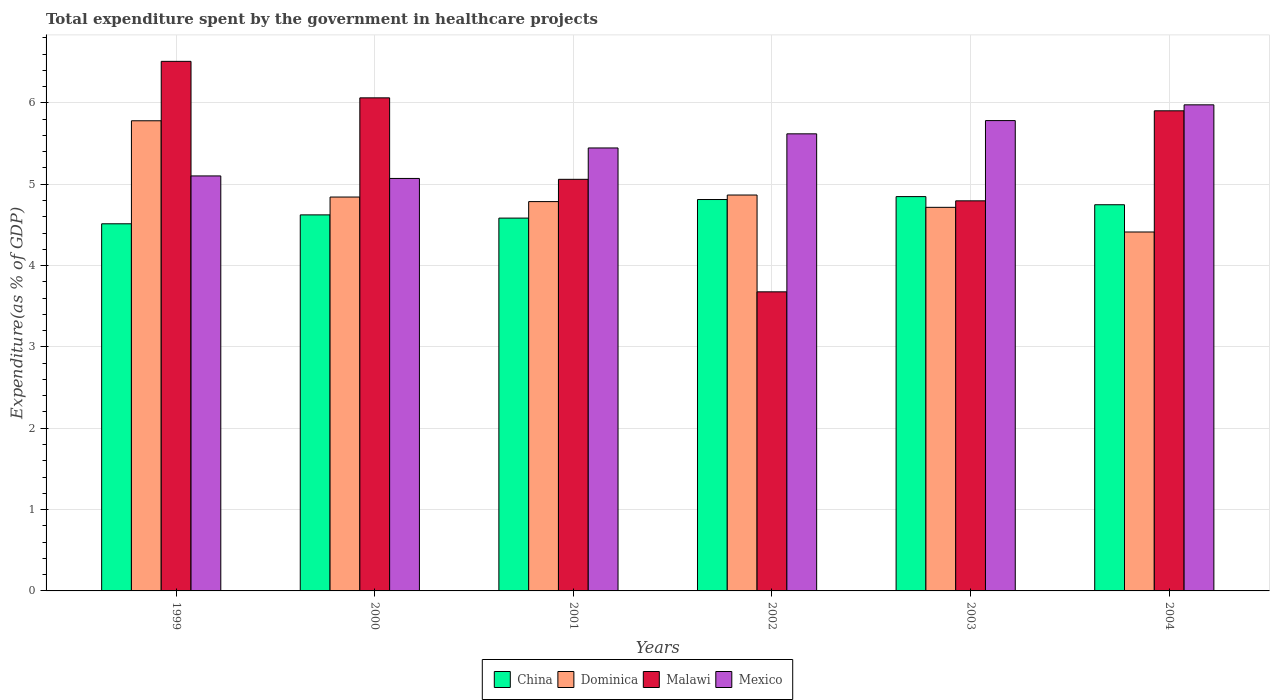How many different coloured bars are there?
Make the answer very short. 4. How many groups of bars are there?
Keep it short and to the point. 6. Are the number of bars on each tick of the X-axis equal?
Offer a very short reply. Yes. How many bars are there on the 1st tick from the right?
Offer a terse response. 4. What is the label of the 3rd group of bars from the left?
Ensure brevity in your answer.  2001. What is the total expenditure spent by the government in healthcare projects in China in 1999?
Provide a short and direct response. 4.51. Across all years, what is the maximum total expenditure spent by the government in healthcare projects in Mexico?
Offer a terse response. 5.98. Across all years, what is the minimum total expenditure spent by the government in healthcare projects in Malawi?
Provide a succinct answer. 3.68. In which year was the total expenditure spent by the government in healthcare projects in China minimum?
Offer a very short reply. 1999. What is the total total expenditure spent by the government in healthcare projects in Malawi in the graph?
Your answer should be compact. 32.01. What is the difference between the total expenditure spent by the government in healthcare projects in Malawi in 2003 and that in 2004?
Give a very brief answer. -1.11. What is the difference between the total expenditure spent by the government in healthcare projects in China in 2003 and the total expenditure spent by the government in healthcare projects in Mexico in 2001?
Ensure brevity in your answer.  -0.6. What is the average total expenditure spent by the government in healthcare projects in Dominica per year?
Ensure brevity in your answer.  4.9. In the year 1999, what is the difference between the total expenditure spent by the government in healthcare projects in Dominica and total expenditure spent by the government in healthcare projects in Malawi?
Give a very brief answer. -0.73. In how many years, is the total expenditure spent by the government in healthcare projects in Dominica greater than 3.4 %?
Provide a short and direct response. 6. What is the ratio of the total expenditure spent by the government in healthcare projects in Malawi in 2002 to that in 2003?
Keep it short and to the point. 0.77. What is the difference between the highest and the second highest total expenditure spent by the government in healthcare projects in Mexico?
Offer a very short reply. 0.19. What is the difference between the highest and the lowest total expenditure spent by the government in healthcare projects in China?
Give a very brief answer. 0.33. In how many years, is the total expenditure spent by the government in healthcare projects in Mexico greater than the average total expenditure spent by the government in healthcare projects in Mexico taken over all years?
Provide a short and direct response. 3. Is the sum of the total expenditure spent by the government in healthcare projects in Mexico in 2001 and 2002 greater than the maximum total expenditure spent by the government in healthcare projects in Dominica across all years?
Make the answer very short. Yes. What does the 4th bar from the right in 1999 represents?
Provide a short and direct response. China. Is it the case that in every year, the sum of the total expenditure spent by the government in healthcare projects in China and total expenditure spent by the government in healthcare projects in Malawi is greater than the total expenditure spent by the government in healthcare projects in Mexico?
Your answer should be compact. Yes. How many bars are there?
Provide a short and direct response. 24. Are all the bars in the graph horizontal?
Offer a terse response. No. How many years are there in the graph?
Keep it short and to the point. 6. What is the difference between two consecutive major ticks on the Y-axis?
Keep it short and to the point. 1. Are the values on the major ticks of Y-axis written in scientific E-notation?
Your answer should be compact. No. Does the graph contain any zero values?
Offer a terse response. No. Does the graph contain grids?
Provide a short and direct response. Yes. Where does the legend appear in the graph?
Offer a terse response. Bottom center. What is the title of the graph?
Give a very brief answer. Total expenditure spent by the government in healthcare projects. What is the label or title of the Y-axis?
Keep it short and to the point. Expenditure(as % of GDP). What is the Expenditure(as % of GDP) in China in 1999?
Keep it short and to the point. 4.51. What is the Expenditure(as % of GDP) in Dominica in 1999?
Offer a terse response. 5.78. What is the Expenditure(as % of GDP) of Malawi in 1999?
Keep it short and to the point. 6.51. What is the Expenditure(as % of GDP) of Mexico in 1999?
Your answer should be compact. 5.1. What is the Expenditure(as % of GDP) of China in 2000?
Ensure brevity in your answer.  4.62. What is the Expenditure(as % of GDP) in Dominica in 2000?
Your answer should be very brief. 4.84. What is the Expenditure(as % of GDP) in Malawi in 2000?
Your response must be concise. 6.06. What is the Expenditure(as % of GDP) in Mexico in 2000?
Provide a succinct answer. 5.07. What is the Expenditure(as % of GDP) of China in 2001?
Offer a very short reply. 4.58. What is the Expenditure(as % of GDP) of Dominica in 2001?
Give a very brief answer. 4.79. What is the Expenditure(as % of GDP) in Malawi in 2001?
Provide a succinct answer. 5.06. What is the Expenditure(as % of GDP) in Mexico in 2001?
Provide a short and direct response. 5.45. What is the Expenditure(as % of GDP) of China in 2002?
Offer a terse response. 4.81. What is the Expenditure(as % of GDP) in Dominica in 2002?
Ensure brevity in your answer.  4.87. What is the Expenditure(as % of GDP) in Malawi in 2002?
Give a very brief answer. 3.68. What is the Expenditure(as % of GDP) in Mexico in 2002?
Provide a short and direct response. 5.62. What is the Expenditure(as % of GDP) of China in 2003?
Your response must be concise. 4.85. What is the Expenditure(as % of GDP) in Dominica in 2003?
Keep it short and to the point. 4.72. What is the Expenditure(as % of GDP) of Malawi in 2003?
Provide a short and direct response. 4.8. What is the Expenditure(as % of GDP) in Mexico in 2003?
Provide a short and direct response. 5.78. What is the Expenditure(as % of GDP) in China in 2004?
Keep it short and to the point. 4.75. What is the Expenditure(as % of GDP) in Dominica in 2004?
Your answer should be compact. 4.41. What is the Expenditure(as % of GDP) of Malawi in 2004?
Provide a short and direct response. 5.9. What is the Expenditure(as % of GDP) of Mexico in 2004?
Your answer should be compact. 5.98. Across all years, what is the maximum Expenditure(as % of GDP) of China?
Give a very brief answer. 4.85. Across all years, what is the maximum Expenditure(as % of GDP) of Dominica?
Provide a succinct answer. 5.78. Across all years, what is the maximum Expenditure(as % of GDP) of Malawi?
Offer a terse response. 6.51. Across all years, what is the maximum Expenditure(as % of GDP) in Mexico?
Give a very brief answer. 5.98. Across all years, what is the minimum Expenditure(as % of GDP) in China?
Offer a very short reply. 4.51. Across all years, what is the minimum Expenditure(as % of GDP) of Dominica?
Your response must be concise. 4.41. Across all years, what is the minimum Expenditure(as % of GDP) in Malawi?
Provide a succinct answer. 3.68. Across all years, what is the minimum Expenditure(as % of GDP) of Mexico?
Offer a very short reply. 5.07. What is the total Expenditure(as % of GDP) of China in the graph?
Offer a very short reply. 28.13. What is the total Expenditure(as % of GDP) in Dominica in the graph?
Make the answer very short. 29.4. What is the total Expenditure(as % of GDP) of Malawi in the graph?
Provide a succinct answer. 32.01. What is the total Expenditure(as % of GDP) in Mexico in the graph?
Provide a short and direct response. 33. What is the difference between the Expenditure(as % of GDP) of China in 1999 and that in 2000?
Offer a terse response. -0.11. What is the difference between the Expenditure(as % of GDP) in Dominica in 1999 and that in 2000?
Offer a terse response. 0.94. What is the difference between the Expenditure(as % of GDP) of Malawi in 1999 and that in 2000?
Provide a succinct answer. 0.45. What is the difference between the Expenditure(as % of GDP) of Mexico in 1999 and that in 2000?
Keep it short and to the point. 0.03. What is the difference between the Expenditure(as % of GDP) of China in 1999 and that in 2001?
Offer a terse response. -0.07. What is the difference between the Expenditure(as % of GDP) of Malawi in 1999 and that in 2001?
Your answer should be very brief. 1.45. What is the difference between the Expenditure(as % of GDP) in Mexico in 1999 and that in 2001?
Keep it short and to the point. -0.34. What is the difference between the Expenditure(as % of GDP) in China in 1999 and that in 2002?
Provide a short and direct response. -0.3. What is the difference between the Expenditure(as % of GDP) of Dominica in 1999 and that in 2002?
Give a very brief answer. 0.91. What is the difference between the Expenditure(as % of GDP) in Malawi in 1999 and that in 2002?
Ensure brevity in your answer.  2.83. What is the difference between the Expenditure(as % of GDP) of Mexico in 1999 and that in 2002?
Your answer should be compact. -0.52. What is the difference between the Expenditure(as % of GDP) of China in 1999 and that in 2003?
Your answer should be compact. -0.33. What is the difference between the Expenditure(as % of GDP) of Dominica in 1999 and that in 2003?
Provide a succinct answer. 1.06. What is the difference between the Expenditure(as % of GDP) in Malawi in 1999 and that in 2003?
Give a very brief answer. 1.71. What is the difference between the Expenditure(as % of GDP) in Mexico in 1999 and that in 2003?
Your answer should be very brief. -0.68. What is the difference between the Expenditure(as % of GDP) of China in 1999 and that in 2004?
Offer a terse response. -0.23. What is the difference between the Expenditure(as % of GDP) of Dominica in 1999 and that in 2004?
Offer a terse response. 1.37. What is the difference between the Expenditure(as % of GDP) in Malawi in 1999 and that in 2004?
Your response must be concise. 0.61. What is the difference between the Expenditure(as % of GDP) of Mexico in 1999 and that in 2004?
Offer a terse response. -0.87. What is the difference between the Expenditure(as % of GDP) of China in 2000 and that in 2001?
Your answer should be very brief. 0.04. What is the difference between the Expenditure(as % of GDP) in Dominica in 2000 and that in 2001?
Ensure brevity in your answer.  0.06. What is the difference between the Expenditure(as % of GDP) in Malawi in 2000 and that in 2001?
Offer a very short reply. 1. What is the difference between the Expenditure(as % of GDP) of Mexico in 2000 and that in 2001?
Your answer should be very brief. -0.37. What is the difference between the Expenditure(as % of GDP) of China in 2000 and that in 2002?
Ensure brevity in your answer.  -0.19. What is the difference between the Expenditure(as % of GDP) of Dominica in 2000 and that in 2002?
Provide a short and direct response. -0.02. What is the difference between the Expenditure(as % of GDP) in Malawi in 2000 and that in 2002?
Make the answer very short. 2.38. What is the difference between the Expenditure(as % of GDP) of Mexico in 2000 and that in 2002?
Give a very brief answer. -0.55. What is the difference between the Expenditure(as % of GDP) in China in 2000 and that in 2003?
Your answer should be very brief. -0.22. What is the difference between the Expenditure(as % of GDP) of Dominica in 2000 and that in 2003?
Your answer should be very brief. 0.13. What is the difference between the Expenditure(as % of GDP) in Malawi in 2000 and that in 2003?
Your response must be concise. 1.27. What is the difference between the Expenditure(as % of GDP) in Mexico in 2000 and that in 2003?
Offer a very short reply. -0.71. What is the difference between the Expenditure(as % of GDP) in China in 2000 and that in 2004?
Give a very brief answer. -0.12. What is the difference between the Expenditure(as % of GDP) of Dominica in 2000 and that in 2004?
Make the answer very short. 0.43. What is the difference between the Expenditure(as % of GDP) in Malawi in 2000 and that in 2004?
Offer a very short reply. 0.16. What is the difference between the Expenditure(as % of GDP) in Mexico in 2000 and that in 2004?
Your response must be concise. -0.9. What is the difference between the Expenditure(as % of GDP) in China in 2001 and that in 2002?
Keep it short and to the point. -0.23. What is the difference between the Expenditure(as % of GDP) in Dominica in 2001 and that in 2002?
Offer a terse response. -0.08. What is the difference between the Expenditure(as % of GDP) of Malawi in 2001 and that in 2002?
Ensure brevity in your answer.  1.38. What is the difference between the Expenditure(as % of GDP) in Mexico in 2001 and that in 2002?
Your response must be concise. -0.17. What is the difference between the Expenditure(as % of GDP) in China in 2001 and that in 2003?
Offer a terse response. -0.26. What is the difference between the Expenditure(as % of GDP) in Dominica in 2001 and that in 2003?
Provide a succinct answer. 0.07. What is the difference between the Expenditure(as % of GDP) of Malawi in 2001 and that in 2003?
Make the answer very short. 0.26. What is the difference between the Expenditure(as % of GDP) in Mexico in 2001 and that in 2003?
Provide a short and direct response. -0.34. What is the difference between the Expenditure(as % of GDP) of China in 2001 and that in 2004?
Offer a very short reply. -0.16. What is the difference between the Expenditure(as % of GDP) in Dominica in 2001 and that in 2004?
Your answer should be compact. 0.37. What is the difference between the Expenditure(as % of GDP) of Malawi in 2001 and that in 2004?
Your response must be concise. -0.84. What is the difference between the Expenditure(as % of GDP) in Mexico in 2001 and that in 2004?
Your answer should be compact. -0.53. What is the difference between the Expenditure(as % of GDP) in China in 2002 and that in 2003?
Ensure brevity in your answer.  -0.04. What is the difference between the Expenditure(as % of GDP) in Dominica in 2002 and that in 2003?
Keep it short and to the point. 0.15. What is the difference between the Expenditure(as % of GDP) of Malawi in 2002 and that in 2003?
Give a very brief answer. -1.12. What is the difference between the Expenditure(as % of GDP) in Mexico in 2002 and that in 2003?
Your answer should be very brief. -0.16. What is the difference between the Expenditure(as % of GDP) of China in 2002 and that in 2004?
Offer a terse response. 0.06. What is the difference between the Expenditure(as % of GDP) in Dominica in 2002 and that in 2004?
Offer a terse response. 0.45. What is the difference between the Expenditure(as % of GDP) in Malawi in 2002 and that in 2004?
Make the answer very short. -2.23. What is the difference between the Expenditure(as % of GDP) of Mexico in 2002 and that in 2004?
Ensure brevity in your answer.  -0.36. What is the difference between the Expenditure(as % of GDP) in China in 2003 and that in 2004?
Offer a very short reply. 0.1. What is the difference between the Expenditure(as % of GDP) of Dominica in 2003 and that in 2004?
Ensure brevity in your answer.  0.3. What is the difference between the Expenditure(as % of GDP) of Malawi in 2003 and that in 2004?
Offer a very short reply. -1.11. What is the difference between the Expenditure(as % of GDP) of Mexico in 2003 and that in 2004?
Offer a very short reply. -0.19. What is the difference between the Expenditure(as % of GDP) of China in 1999 and the Expenditure(as % of GDP) of Dominica in 2000?
Offer a very short reply. -0.33. What is the difference between the Expenditure(as % of GDP) of China in 1999 and the Expenditure(as % of GDP) of Malawi in 2000?
Provide a succinct answer. -1.55. What is the difference between the Expenditure(as % of GDP) in China in 1999 and the Expenditure(as % of GDP) in Mexico in 2000?
Make the answer very short. -0.56. What is the difference between the Expenditure(as % of GDP) in Dominica in 1999 and the Expenditure(as % of GDP) in Malawi in 2000?
Your response must be concise. -0.28. What is the difference between the Expenditure(as % of GDP) of Dominica in 1999 and the Expenditure(as % of GDP) of Mexico in 2000?
Offer a terse response. 0.71. What is the difference between the Expenditure(as % of GDP) in Malawi in 1999 and the Expenditure(as % of GDP) in Mexico in 2000?
Make the answer very short. 1.44. What is the difference between the Expenditure(as % of GDP) of China in 1999 and the Expenditure(as % of GDP) of Dominica in 2001?
Provide a succinct answer. -0.27. What is the difference between the Expenditure(as % of GDP) of China in 1999 and the Expenditure(as % of GDP) of Malawi in 2001?
Offer a very short reply. -0.55. What is the difference between the Expenditure(as % of GDP) in China in 1999 and the Expenditure(as % of GDP) in Mexico in 2001?
Provide a succinct answer. -0.93. What is the difference between the Expenditure(as % of GDP) of Dominica in 1999 and the Expenditure(as % of GDP) of Malawi in 2001?
Make the answer very short. 0.72. What is the difference between the Expenditure(as % of GDP) in Dominica in 1999 and the Expenditure(as % of GDP) in Mexico in 2001?
Your response must be concise. 0.33. What is the difference between the Expenditure(as % of GDP) of Malawi in 1999 and the Expenditure(as % of GDP) of Mexico in 2001?
Give a very brief answer. 1.06. What is the difference between the Expenditure(as % of GDP) of China in 1999 and the Expenditure(as % of GDP) of Dominica in 2002?
Give a very brief answer. -0.35. What is the difference between the Expenditure(as % of GDP) of China in 1999 and the Expenditure(as % of GDP) of Malawi in 2002?
Make the answer very short. 0.84. What is the difference between the Expenditure(as % of GDP) in China in 1999 and the Expenditure(as % of GDP) in Mexico in 2002?
Offer a terse response. -1.11. What is the difference between the Expenditure(as % of GDP) in Dominica in 1999 and the Expenditure(as % of GDP) in Malawi in 2002?
Your answer should be compact. 2.1. What is the difference between the Expenditure(as % of GDP) in Dominica in 1999 and the Expenditure(as % of GDP) in Mexico in 2002?
Offer a very short reply. 0.16. What is the difference between the Expenditure(as % of GDP) in Malawi in 1999 and the Expenditure(as % of GDP) in Mexico in 2002?
Your response must be concise. 0.89. What is the difference between the Expenditure(as % of GDP) in China in 1999 and the Expenditure(as % of GDP) in Dominica in 2003?
Offer a very short reply. -0.2. What is the difference between the Expenditure(as % of GDP) of China in 1999 and the Expenditure(as % of GDP) of Malawi in 2003?
Keep it short and to the point. -0.28. What is the difference between the Expenditure(as % of GDP) in China in 1999 and the Expenditure(as % of GDP) in Mexico in 2003?
Provide a succinct answer. -1.27. What is the difference between the Expenditure(as % of GDP) of Dominica in 1999 and the Expenditure(as % of GDP) of Malawi in 2003?
Provide a succinct answer. 0.98. What is the difference between the Expenditure(as % of GDP) in Dominica in 1999 and the Expenditure(as % of GDP) in Mexico in 2003?
Offer a very short reply. -0. What is the difference between the Expenditure(as % of GDP) of Malawi in 1999 and the Expenditure(as % of GDP) of Mexico in 2003?
Give a very brief answer. 0.73. What is the difference between the Expenditure(as % of GDP) in China in 1999 and the Expenditure(as % of GDP) in Dominica in 2004?
Provide a short and direct response. 0.1. What is the difference between the Expenditure(as % of GDP) in China in 1999 and the Expenditure(as % of GDP) in Malawi in 2004?
Your answer should be compact. -1.39. What is the difference between the Expenditure(as % of GDP) of China in 1999 and the Expenditure(as % of GDP) of Mexico in 2004?
Offer a terse response. -1.46. What is the difference between the Expenditure(as % of GDP) in Dominica in 1999 and the Expenditure(as % of GDP) in Malawi in 2004?
Make the answer very short. -0.12. What is the difference between the Expenditure(as % of GDP) of Dominica in 1999 and the Expenditure(as % of GDP) of Mexico in 2004?
Provide a short and direct response. -0.2. What is the difference between the Expenditure(as % of GDP) of Malawi in 1999 and the Expenditure(as % of GDP) of Mexico in 2004?
Offer a terse response. 0.53. What is the difference between the Expenditure(as % of GDP) of China in 2000 and the Expenditure(as % of GDP) of Dominica in 2001?
Give a very brief answer. -0.16. What is the difference between the Expenditure(as % of GDP) in China in 2000 and the Expenditure(as % of GDP) in Malawi in 2001?
Ensure brevity in your answer.  -0.44. What is the difference between the Expenditure(as % of GDP) in China in 2000 and the Expenditure(as % of GDP) in Mexico in 2001?
Offer a terse response. -0.82. What is the difference between the Expenditure(as % of GDP) of Dominica in 2000 and the Expenditure(as % of GDP) of Malawi in 2001?
Keep it short and to the point. -0.22. What is the difference between the Expenditure(as % of GDP) in Dominica in 2000 and the Expenditure(as % of GDP) in Mexico in 2001?
Make the answer very short. -0.6. What is the difference between the Expenditure(as % of GDP) in Malawi in 2000 and the Expenditure(as % of GDP) in Mexico in 2001?
Provide a succinct answer. 0.62. What is the difference between the Expenditure(as % of GDP) of China in 2000 and the Expenditure(as % of GDP) of Dominica in 2002?
Provide a succinct answer. -0.24. What is the difference between the Expenditure(as % of GDP) of China in 2000 and the Expenditure(as % of GDP) of Malawi in 2002?
Ensure brevity in your answer.  0.95. What is the difference between the Expenditure(as % of GDP) of China in 2000 and the Expenditure(as % of GDP) of Mexico in 2002?
Provide a short and direct response. -1. What is the difference between the Expenditure(as % of GDP) of Dominica in 2000 and the Expenditure(as % of GDP) of Malawi in 2002?
Offer a terse response. 1.17. What is the difference between the Expenditure(as % of GDP) of Dominica in 2000 and the Expenditure(as % of GDP) of Mexico in 2002?
Offer a terse response. -0.78. What is the difference between the Expenditure(as % of GDP) of Malawi in 2000 and the Expenditure(as % of GDP) of Mexico in 2002?
Provide a succinct answer. 0.44. What is the difference between the Expenditure(as % of GDP) in China in 2000 and the Expenditure(as % of GDP) in Dominica in 2003?
Offer a very short reply. -0.09. What is the difference between the Expenditure(as % of GDP) in China in 2000 and the Expenditure(as % of GDP) in Malawi in 2003?
Offer a very short reply. -0.17. What is the difference between the Expenditure(as % of GDP) of China in 2000 and the Expenditure(as % of GDP) of Mexico in 2003?
Give a very brief answer. -1.16. What is the difference between the Expenditure(as % of GDP) in Dominica in 2000 and the Expenditure(as % of GDP) in Malawi in 2003?
Provide a short and direct response. 0.05. What is the difference between the Expenditure(as % of GDP) in Dominica in 2000 and the Expenditure(as % of GDP) in Mexico in 2003?
Give a very brief answer. -0.94. What is the difference between the Expenditure(as % of GDP) of Malawi in 2000 and the Expenditure(as % of GDP) of Mexico in 2003?
Give a very brief answer. 0.28. What is the difference between the Expenditure(as % of GDP) in China in 2000 and the Expenditure(as % of GDP) in Dominica in 2004?
Make the answer very short. 0.21. What is the difference between the Expenditure(as % of GDP) in China in 2000 and the Expenditure(as % of GDP) in Malawi in 2004?
Offer a very short reply. -1.28. What is the difference between the Expenditure(as % of GDP) in China in 2000 and the Expenditure(as % of GDP) in Mexico in 2004?
Provide a succinct answer. -1.35. What is the difference between the Expenditure(as % of GDP) in Dominica in 2000 and the Expenditure(as % of GDP) in Malawi in 2004?
Your response must be concise. -1.06. What is the difference between the Expenditure(as % of GDP) of Dominica in 2000 and the Expenditure(as % of GDP) of Mexico in 2004?
Keep it short and to the point. -1.13. What is the difference between the Expenditure(as % of GDP) of Malawi in 2000 and the Expenditure(as % of GDP) of Mexico in 2004?
Make the answer very short. 0.09. What is the difference between the Expenditure(as % of GDP) of China in 2001 and the Expenditure(as % of GDP) of Dominica in 2002?
Provide a short and direct response. -0.28. What is the difference between the Expenditure(as % of GDP) of China in 2001 and the Expenditure(as % of GDP) of Malawi in 2002?
Give a very brief answer. 0.91. What is the difference between the Expenditure(as % of GDP) of China in 2001 and the Expenditure(as % of GDP) of Mexico in 2002?
Ensure brevity in your answer.  -1.04. What is the difference between the Expenditure(as % of GDP) of Dominica in 2001 and the Expenditure(as % of GDP) of Malawi in 2002?
Make the answer very short. 1.11. What is the difference between the Expenditure(as % of GDP) in Dominica in 2001 and the Expenditure(as % of GDP) in Mexico in 2002?
Your answer should be very brief. -0.83. What is the difference between the Expenditure(as % of GDP) of Malawi in 2001 and the Expenditure(as % of GDP) of Mexico in 2002?
Your answer should be very brief. -0.56. What is the difference between the Expenditure(as % of GDP) in China in 2001 and the Expenditure(as % of GDP) in Dominica in 2003?
Ensure brevity in your answer.  -0.13. What is the difference between the Expenditure(as % of GDP) in China in 2001 and the Expenditure(as % of GDP) in Malawi in 2003?
Give a very brief answer. -0.21. What is the difference between the Expenditure(as % of GDP) in China in 2001 and the Expenditure(as % of GDP) in Mexico in 2003?
Give a very brief answer. -1.2. What is the difference between the Expenditure(as % of GDP) in Dominica in 2001 and the Expenditure(as % of GDP) in Malawi in 2003?
Offer a very short reply. -0.01. What is the difference between the Expenditure(as % of GDP) in Dominica in 2001 and the Expenditure(as % of GDP) in Mexico in 2003?
Your answer should be compact. -1. What is the difference between the Expenditure(as % of GDP) in Malawi in 2001 and the Expenditure(as % of GDP) in Mexico in 2003?
Make the answer very short. -0.72. What is the difference between the Expenditure(as % of GDP) of China in 2001 and the Expenditure(as % of GDP) of Dominica in 2004?
Give a very brief answer. 0.17. What is the difference between the Expenditure(as % of GDP) of China in 2001 and the Expenditure(as % of GDP) of Malawi in 2004?
Offer a terse response. -1.32. What is the difference between the Expenditure(as % of GDP) in China in 2001 and the Expenditure(as % of GDP) in Mexico in 2004?
Offer a terse response. -1.39. What is the difference between the Expenditure(as % of GDP) of Dominica in 2001 and the Expenditure(as % of GDP) of Malawi in 2004?
Offer a very short reply. -1.12. What is the difference between the Expenditure(as % of GDP) of Dominica in 2001 and the Expenditure(as % of GDP) of Mexico in 2004?
Offer a terse response. -1.19. What is the difference between the Expenditure(as % of GDP) of Malawi in 2001 and the Expenditure(as % of GDP) of Mexico in 2004?
Provide a succinct answer. -0.92. What is the difference between the Expenditure(as % of GDP) in China in 2002 and the Expenditure(as % of GDP) in Dominica in 2003?
Offer a very short reply. 0.1. What is the difference between the Expenditure(as % of GDP) in China in 2002 and the Expenditure(as % of GDP) in Malawi in 2003?
Ensure brevity in your answer.  0.02. What is the difference between the Expenditure(as % of GDP) in China in 2002 and the Expenditure(as % of GDP) in Mexico in 2003?
Give a very brief answer. -0.97. What is the difference between the Expenditure(as % of GDP) in Dominica in 2002 and the Expenditure(as % of GDP) in Malawi in 2003?
Your response must be concise. 0.07. What is the difference between the Expenditure(as % of GDP) of Dominica in 2002 and the Expenditure(as % of GDP) of Mexico in 2003?
Your answer should be compact. -0.92. What is the difference between the Expenditure(as % of GDP) in Malawi in 2002 and the Expenditure(as % of GDP) in Mexico in 2003?
Keep it short and to the point. -2.11. What is the difference between the Expenditure(as % of GDP) of China in 2002 and the Expenditure(as % of GDP) of Dominica in 2004?
Your answer should be very brief. 0.4. What is the difference between the Expenditure(as % of GDP) of China in 2002 and the Expenditure(as % of GDP) of Malawi in 2004?
Offer a terse response. -1.09. What is the difference between the Expenditure(as % of GDP) in China in 2002 and the Expenditure(as % of GDP) in Mexico in 2004?
Ensure brevity in your answer.  -1.16. What is the difference between the Expenditure(as % of GDP) in Dominica in 2002 and the Expenditure(as % of GDP) in Malawi in 2004?
Ensure brevity in your answer.  -1.04. What is the difference between the Expenditure(as % of GDP) in Dominica in 2002 and the Expenditure(as % of GDP) in Mexico in 2004?
Offer a very short reply. -1.11. What is the difference between the Expenditure(as % of GDP) of Malawi in 2002 and the Expenditure(as % of GDP) of Mexico in 2004?
Provide a short and direct response. -2.3. What is the difference between the Expenditure(as % of GDP) of China in 2003 and the Expenditure(as % of GDP) of Dominica in 2004?
Your answer should be compact. 0.43. What is the difference between the Expenditure(as % of GDP) in China in 2003 and the Expenditure(as % of GDP) in Malawi in 2004?
Provide a short and direct response. -1.05. What is the difference between the Expenditure(as % of GDP) in China in 2003 and the Expenditure(as % of GDP) in Mexico in 2004?
Offer a terse response. -1.13. What is the difference between the Expenditure(as % of GDP) in Dominica in 2003 and the Expenditure(as % of GDP) in Malawi in 2004?
Give a very brief answer. -1.19. What is the difference between the Expenditure(as % of GDP) of Dominica in 2003 and the Expenditure(as % of GDP) of Mexico in 2004?
Provide a succinct answer. -1.26. What is the difference between the Expenditure(as % of GDP) of Malawi in 2003 and the Expenditure(as % of GDP) of Mexico in 2004?
Offer a terse response. -1.18. What is the average Expenditure(as % of GDP) of China per year?
Give a very brief answer. 4.69. What is the average Expenditure(as % of GDP) of Dominica per year?
Make the answer very short. 4.9. What is the average Expenditure(as % of GDP) in Malawi per year?
Your answer should be compact. 5.33. What is the average Expenditure(as % of GDP) in Mexico per year?
Offer a very short reply. 5.5. In the year 1999, what is the difference between the Expenditure(as % of GDP) in China and Expenditure(as % of GDP) in Dominica?
Keep it short and to the point. -1.27. In the year 1999, what is the difference between the Expenditure(as % of GDP) of China and Expenditure(as % of GDP) of Malawi?
Provide a short and direct response. -2. In the year 1999, what is the difference between the Expenditure(as % of GDP) in China and Expenditure(as % of GDP) in Mexico?
Ensure brevity in your answer.  -0.59. In the year 1999, what is the difference between the Expenditure(as % of GDP) in Dominica and Expenditure(as % of GDP) in Malawi?
Provide a succinct answer. -0.73. In the year 1999, what is the difference between the Expenditure(as % of GDP) in Dominica and Expenditure(as % of GDP) in Mexico?
Ensure brevity in your answer.  0.68. In the year 1999, what is the difference between the Expenditure(as % of GDP) in Malawi and Expenditure(as % of GDP) in Mexico?
Ensure brevity in your answer.  1.41. In the year 2000, what is the difference between the Expenditure(as % of GDP) of China and Expenditure(as % of GDP) of Dominica?
Offer a terse response. -0.22. In the year 2000, what is the difference between the Expenditure(as % of GDP) of China and Expenditure(as % of GDP) of Malawi?
Keep it short and to the point. -1.44. In the year 2000, what is the difference between the Expenditure(as % of GDP) of China and Expenditure(as % of GDP) of Mexico?
Make the answer very short. -0.45. In the year 2000, what is the difference between the Expenditure(as % of GDP) in Dominica and Expenditure(as % of GDP) in Malawi?
Your answer should be compact. -1.22. In the year 2000, what is the difference between the Expenditure(as % of GDP) in Dominica and Expenditure(as % of GDP) in Mexico?
Your response must be concise. -0.23. In the year 2000, what is the difference between the Expenditure(as % of GDP) of Malawi and Expenditure(as % of GDP) of Mexico?
Keep it short and to the point. 0.99. In the year 2001, what is the difference between the Expenditure(as % of GDP) in China and Expenditure(as % of GDP) in Dominica?
Offer a very short reply. -0.2. In the year 2001, what is the difference between the Expenditure(as % of GDP) in China and Expenditure(as % of GDP) in Malawi?
Your answer should be compact. -0.48. In the year 2001, what is the difference between the Expenditure(as % of GDP) of China and Expenditure(as % of GDP) of Mexico?
Make the answer very short. -0.86. In the year 2001, what is the difference between the Expenditure(as % of GDP) of Dominica and Expenditure(as % of GDP) of Malawi?
Make the answer very short. -0.27. In the year 2001, what is the difference between the Expenditure(as % of GDP) in Dominica and Expenditure(as % of GDP) in Mexico?
Your answer should be very brief. -0.66. In the year 2001, what is the difference between the Expenditure(as % of GDP) in Malawi and Expenditure(as % of GDP) in Mexico?
Your response must be concise. -0.39. In the year 2002, what is the difference between the Expenditure(as % of GDP) in China and Expenditure(as % of GDP) in Dominica?
Provide a succinct answer. -0.06. In the year 2002, what is the difference between the Expenditure(as % of GDP) in China and Expenditure(as % of GDP) in Malawi?
Your answer should be compact. 1.13. In the year 2002, what is the difference between the Expenditure(as % of GDP) in China and Expenditure(as % of GDP) in Mexico?
Provide a short and direct response. -0.81. In the year 2002, what is the difference between the Expenditure(as % of GDP) in Dominica and Expenditure(as % of GDP) in Malawi?
Give a very brief answer. 1.19. In the year 2002, what is the difference between the Expenditure(as % of GDP) in Dominica and Expenditure(as % of GDP) in Mexico?
Your response must be concise. -0.75. In the year 2002, what is the difference between the Expenditure(as % of GDP) in Malawi and Expenditure(as % of GDP) in Mexico?
Make the answer very short. -1.94. In the year 2003, what is the difference between the Expenditure(as % of GDP) in China and Expenditure(as % of GDP) in Dominica?
Provide a succinct answer. 0.13. In the year 2003, what is the difference between the Expenditure(as % of GDP) of China and Expenditure(as % of GDP) of Malawi?
Keep it short and to the point. 0.05. In the year 2003, what is the difference between the Expenditure(as % of GDP) of China and Expenditure(as % of GDP) of Mexico?
Offer a very short reply. -0.93. In the year 2003, what is the difference between the Expenditure(as % of GDP) in Dominica and Expenditure(as % of GDP) in Malawi?
Provide a succinct answer. -0.08. In the year 2003, what is the difference between the Expenditure(as % of GDP) of Dominica and Expenditure(as % of GDP) of Mexico?
Provide a succinct answer. -1.07. In the year 2003, what is the difference between the Expenditure(as % of GDP) in Malawi and Expenditure(as % of GDP) in Mexico?
Your answer should be very brief. -0.99. In the year 2004, what is the difference between the Expenditure(as % of GDP) of China and Expenditure(as % of GDP) of Dominica?
Make the answer very short. 0.34. In the year 2004, what is the difference between the Expenditure(as % of GDP) in China and Expenditure(as % of GDP) in Malawi?
Keep it short and to the point. -1.15. In the year 2004, what is the difference between the Expenditure(as % of GDP) of China and Expenditure(as % of GDP) of Mexico?
Ensure brevity in your answer.  -1.23. In the year 2004, what is the difference between the Expenditure(as % of GDP) of Dominica and Expenditure(as % of GDP) of Malawi?
Offer a terse response. -1.49. In the year 2004, what is the difference between the Expenditure(as % of GDP) in Dominica and Expenditure(as % of GDP) in Mexico?
Give a very brief answer. -1.56. In the year 2004, what is the difference between the Expenditure(as % of GDP) of Malawi and Expenditure(as % of GDP) of Mexico?
Offer a terse response. -0.07. What is the ratio of the Expenditure(as % of GDP) in China in 1999 to that in 2000?
Provide a succinct answer. 0.98. What is the ratio of the Expenditure(as % of GDP) in Dominica in 1999 to that in 2000?
Your answer should be very brief. 1.19. What is the ratio of the Expenditure(as % of GDP) in Malawi in 1999 to that in 2000?
Your answer should be compact. 1.07. What is the ratio of the Expenditure(as % of GDP) in China in 1999 to that in 2001?
Your answer should be compact. 0.98. What is the ratio of the Expenditure(as % of GDP) of Dominica in 1999 to that in 2001?
Offer a terse response. 1.21. What is the ratio of the Expenditure(as % of GDP) of Malawi in 1999 to that in 2001?
Your response must be concise. 1.29. What is the ratio of the Expenditure(as % of GDP) of Mexico in 1999 to that in 2001?
Provide a short and direct response. 0.94. What is the ratio of the Expenditure(as % of GDP) in China in 1999 to that in 2002?
Offer a terse response. 0.94. What is the ratio of the Expenditure(as % of GDP) in Dominica in 1999 to that in 2002?
Offer a terse response. 1.19. What is the ratio of the Expenditure(as % of GDP) of Malawi in 1999 to that in 2002?
Your response must be concise. 1.77. What is the ratio of the Expenditure(as % of GDP) in Mexico in 1999 to that in 2002?
Ensure brevity in your answer.  0.91. What is the ratio of the Expenditure(as % of GDP) of China in 1999 to that in 2003?
Your response must be concise. 0.93. What is the ratio of the Expenditure(as % of GDP) of Dominica in 1999 to that in 2003?
Offer a terse response. 1.23. What is the ratio of the Expenditure(as % of GDP) of Malawi in 1999 to that in 2003?
Make the answer very short. 1.36. What is the ratio of the Expenditure(as % of GDP) in Mexico in 1999 to that in 2003?
Your answer should be compact. 0.88. What is the ratio of the Expenditure(as % of GDP) in China in 1999 to that in 2004?
Your answer should be very brief. 0.95. What is the ratio of the Expenditure(as % of GDP) of Dominica in 1999 to that in 2004?
Give a very brief answer. 1.31. What is the ratio of the Expenditure(as % of GDP) of Malawi in 1999 to that in 2004?
Your answer should be compact. 1.1. What is the ratio of the Expenditure(as % of GDP) in Mexico in 1999 to that in 2004?
Give a very brief answer. 0.85. What is the ratio of the Expenditure(as % of GDP) of China in 2000 to that in 2001?
Your answer should be compact. 1.01. What is the ratio of the Expenditure(as % of GDP) of Dominica in 2000 to that in 2001?
Ensure brevity in your answer.  1.01. What is the ratio of the Expenditure(as % of GDP) of Malawi in 2000 to that in 2001?
Give a very brief answer. 1.2. What is the ratio of the Expenditure(as % of GDP) in Mexico in 2000 to that in 2001?
Your response must be concise. 0.93. What is the ratio of the Expenditure(as % of GDP) in China in 2000 to that in 2002?
Give a very brief answer. 0.96. What is the ratio of the Expenditure(as % of GDP) in Dominica in 2000 to that in 2002?
Offer a very short reply. 0.99. What is the ratio of the Expenditure(as % of GDP) of Malawi in 2000 to that in 2002?
Your response must be concise. 1.65. What is the ratio of the Expenditure(as % of GDP) of Mexico in 2000 to that in 2002?
Provide a short and direct response. 0.9. What is the ratio of the Expenditure(as % of GDP) in China in 2000 to that in 2003?
Your answer should be compact. 0.95. What is the ratio of the Expenditure(as % of GDP) of Dominica in 2000 to that in 2003?
Your response must be concise. 1.03. What is the ratio of the Expenditure(as % of GDP) in Malawi in 2000 to that in 2003?
Provide a succinct answer. 1.26. What is the ratio of the Expenditure(as % of GDP) of Mexico in 2000 to that in 2003?
Keep it short and to the point. 0.88. What is the ratio of the Expenditure(as % of GDP) in China in 2000 to that in 2004?
Your answer should be very brief. 0.97. What is the ratio of the Expenditure(as % of GDP) in Dominica in 2000 to that in 2004?
Make the answer very short. 1.1. What is the ratio of the Expenditure(as % of GDP) in Mexico in 2000 to that in 2004?
Keep it short and to the point. 0.85. What is the ratio of the Expenditure(as % of GDP) of China in 2001 to that in 2002?
Offer a terse response. 0.95. What is the ratio of the Expenditure(as % of GDP) in Dominica in 2001 to that in 2002?
Offer a terse response. 0.98. What is the ratio of the Expenditure(as % of GDP) in Malawi in 2001 to that in 2002?
Give a very brief answer. 1.38. What is the ratio of the Expenditure(as % of GDP) of Mexico in 2001 to that in 2002?
Provide a succinct answer. 0.97. What is the ratio of the Expenditure(as % of GDP) in China in 2001 to that in 2003?
Your answer should be compact. 0.95. What is the ratio of the Expenditure(as % of GDP) of Malawi in 2001 to that in 2003?
Keep it short and to the point. 1.06. What is the ratio of the Expenditure(as % of GDP) of Mexico in 2001 to that in 2003?
Provide a short and direct response. 0.94. What is the ratio of the Expenditure(as % of GDP) in China in 2001 to that in 2004?
Your response must be concise. 0.97. What is the ratio of the Expenditure(as % of GDP) in Dominica in 2001 to that in 2004?
Ensure brevity in your answer.  1.08. What is the ratio of the Expenditure(as % of GDP) of Malawi in 2001 to that in 2004?
Offer a terse response. 0.86. What is the ratio of the Expenditure(as % of GDP) of Mexico in 2001 to that in 2004?
Your answer should be very brief. 0.91. What is the ratio of the Expenditure(as % of GDP) of Dominica in 2002 to that in 2003?
Provide a succinct answer. 1.03. What is the ratio of the Expenditure(as % of GDP) in Malawi in 2002 to that in 2003?
Your response must be concise. 0.77. What is the ratio of the Expenditure(as % of GDP) in Mexico in 2002 to that in 2003?
Make the answer very short. 0.97. What is the ratio of the Expenditure(as % of GDP) in China in 2002 to that in 2004?
Ensure brevity in your answer.  1.01. What is the ratio of the Expenditure(as % of GDP) of Dominica in 2002 to that in 2004?
Offer a very short reply. 1.1. What is the ratio of the Expenditure(as % of GDP) of Malawi in 2002 to that in 2004?
Your answer should be very brief. 0.62. What is the ratio of the Expenditure(as % of GDP) in Mexico in 2002 to that in 2004?
Provide a short and direct response. 0.94. What is the ratio of the Expenditure(as % of GDP) of China in 2003 to that in 2004?
Offer a very short reply. 1.02. What is the ratio of the Expenditure(as % of GDP) of Dominica in 2003 to that in 2004?
Your answer should be compact. 1.07. What is the ratio of the Expenditure(as % of GDP) of Malawi in 2003 to that in 2004?
Ensure brevity in your answer.  0.81. What is the ratio of the Expenditure(as % of GDP) of Mexico in 2003 to that in 2004?
Your response must be concise. 0.97. What is the difference between the highest and the second highest Expenditure(as % of GDP) of China?
Your answer should be compact. 0.04. What is the difference between the highest and the second highest Expenditure(as % of GDP) of Dominica?
Your answer should be very brief. 0.91. What is the difference between the highest and the second highest Expenditure(as % of GDP) in Malawi?
Ensure brevity in your answer.  0.45. What is the difference between the highest and the second highest Expenditure(as % of GDP) of Mexico?
Provide a short and direct response. 0.19. What is the difference between the highest and the lowest Expenditure(as % of GDP) of China?
Make the answer very short. 0.33. What is the difference between the highest and the lowest Expenditure(as % of GDP) of Dominica?
Your answer should be compact. 1.37. What is the difference between the highest and the lowest Expenditure(as % of GDP) in Malawi?
Your response must be concise. 2.83. What is the difference between the highest and the lowest Expenditure(as % of GDP) of Mexico?
Provide a succinct answer. 0.9. 